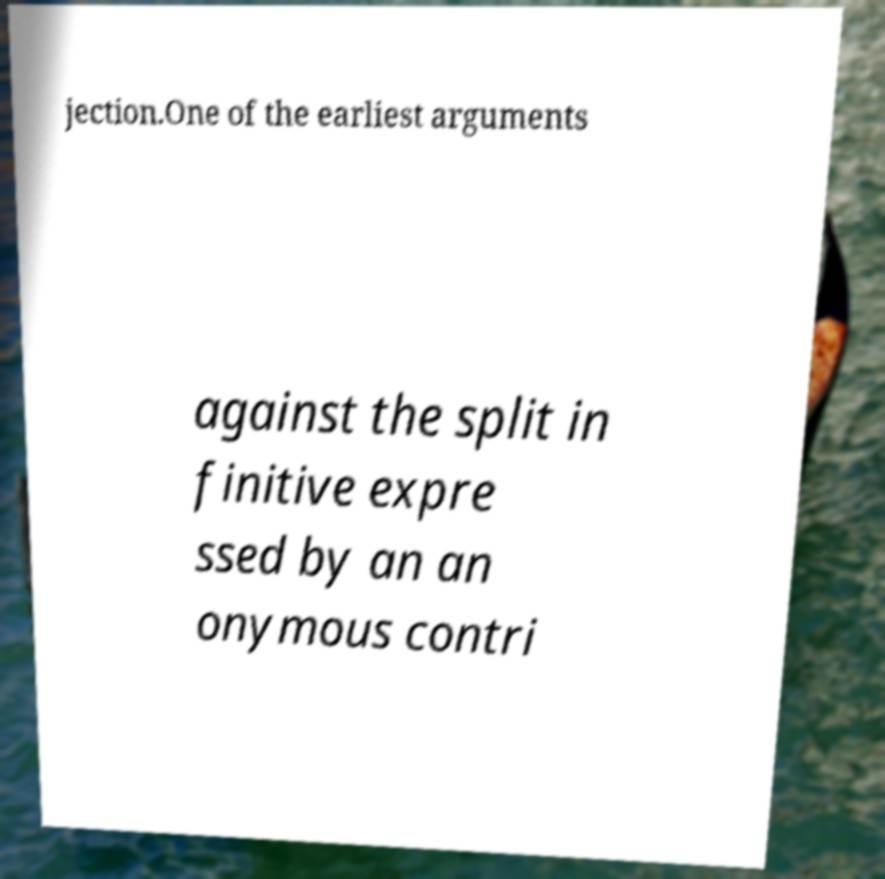Please identify and transcribe the text found in this image. jection.One of the earliest arguments against the split in finitive expre ssed by an an onymous contri 